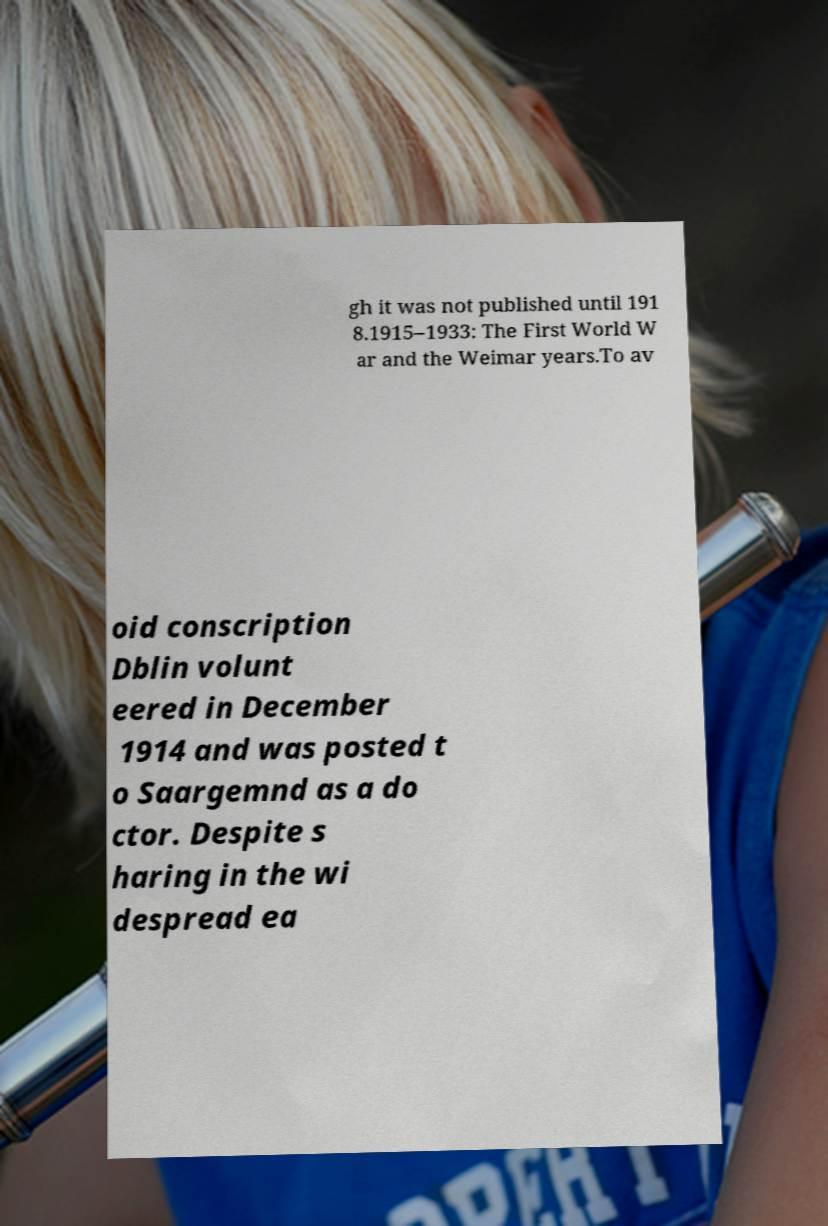There's text embedded in this image that I need extracted. Can you transcribe it verbatim? gh it was not published until 191 8.1915–1933: The First World W ar and the Weimar years.To av oid conscription Dblin volunt eered in December 1914 and was posted t o Saargemnd as a do ctor. Despite s haring in the wi despread ea 